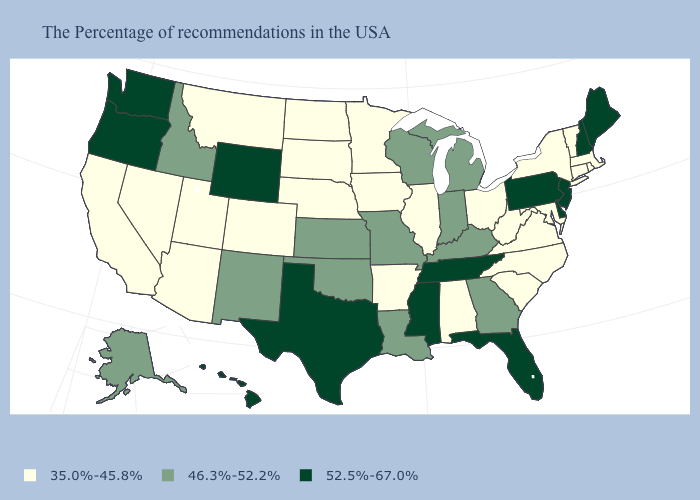What is the value of Arizona?
Concise answer only. 35.0%-45.8%. How many symbols are there in the legend?
Write a very short answer. 3. Which states have the lowest value in the West?
Concise answer only. Colorado, Utah, Montana, Arizona, Nevada, California. What is the lowest value in the MidWest?
Write a very short answer. 35.0%-45.8%. Name the states that have a value in the range 35.0%-45.8%?
Short answer required. Massachusetts, Rhode Island, Vermont, Connecticut, New York, Maryland, Virginia, North Carolina, South Carolina, West Virginia, Ohio, Alabama, Illinois, Arkansas, Minnesota, Iowa, Nebraska, South Dakota, North Dakota, Colorado, Utah, Montana, Arizona, Nevada, California. What is the highest value in the USA?
Be succinct. 52.5%-67.0%. Among the states that border Iowa , does Illinois have the highest value?
Quick response, please. No. Name the states that have a value in the range 35.0%-45.8%?
Quick response, please. Massachusetts, Rhode Island, Vermont, Connecticut, New York, Maryland, Virginia, North Carolina, South Carolina, West Virginia, Ohio, Alabama, Illinois, Arkansas, Minnesota, Iowa, Nebraska, South Dakota, North Dakota, Colorado, Utah, Montana, Arizona, Nevada, California. Is the legend a continuous bar?
Short answer required. No. Is the legend a continuous bar?
Answer briefly. No. What is the lowest value in the West?
Concise answer only. 35.0%-45.8%. Name the states that have a value in the range 52.5%-67.0%?
Quick response, please. Maine, New Hampshire, New Jersey, Delaware, Pennsylvania, Florida, Tennessee, Mississippi, Texas, Wyoming, Washington, Oregon, Hawaii. Name the states that have a value in the range 46.3%-52.2%?
Keep it brief. Georgia, Michigan, Kentucky, Indiana, Wisconsin, Louisiana, Missouri, Kansas, Oklahoma, New Mexico, Idaho, Alaska. Name the states that have a value in the range 52.5%-67.0%?
Give a very brief answer. Maine, New Hampshire, New Jersey, Delaware, Pennsylvania, Florida, Tennessee, Mississippi, Texas, Wyoming, Washington, Oregon, Hawaii. What is the value of Massachusetts?
Give a very brief answer. 35.0%-45.8%. 